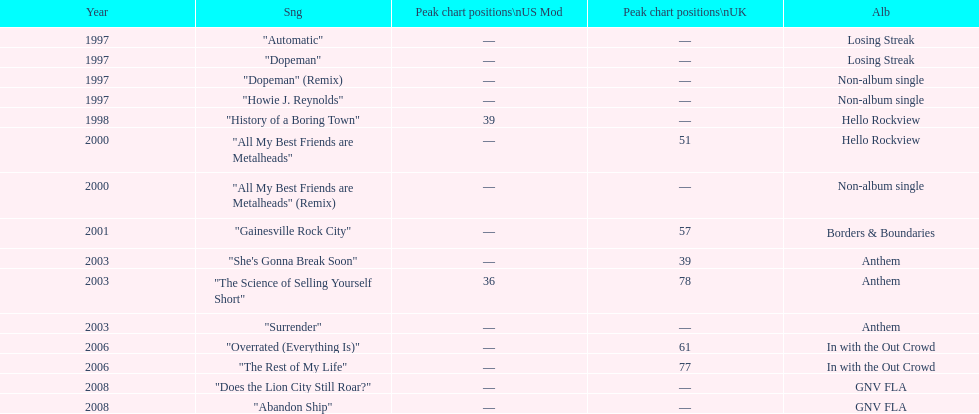How long was it between losing streak almbum and gnv fla in years. 11. 